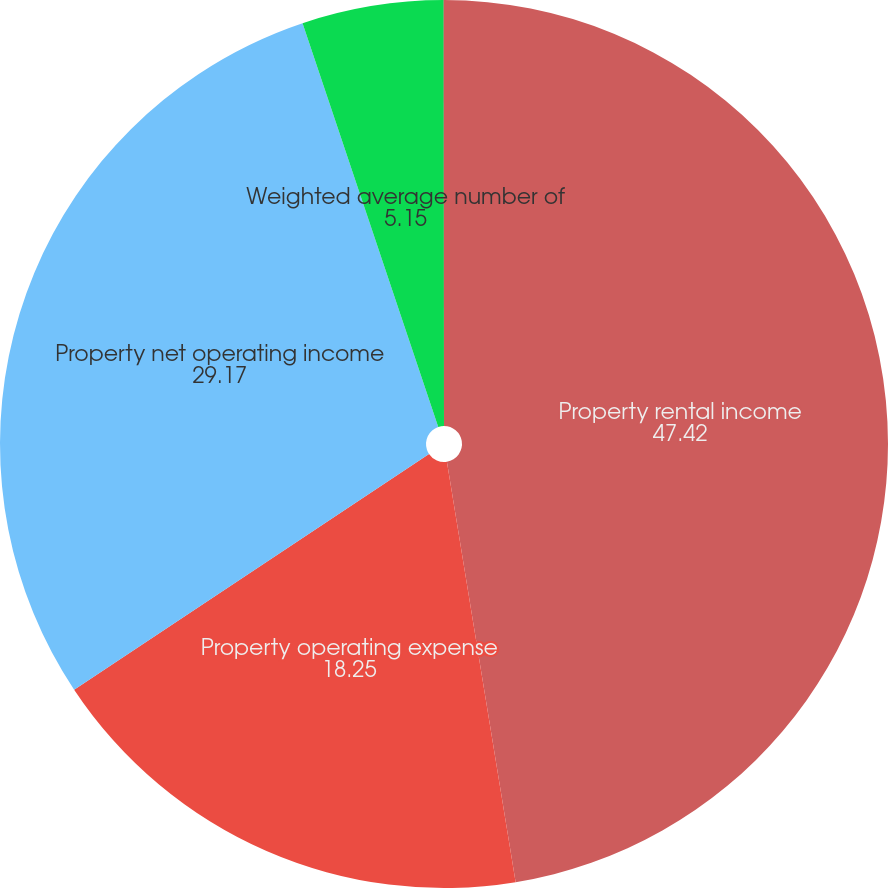Convert chart. <chart><loc_0><loc_0><loc_500><loc_500><pie_chart><fcel>Property rental income<fcel>Property operating expense<fcel>Property net operating income<fcel>Weighted average number of<fcel>Physical occupancy<nl><fcel>47.42%<fcel>18.25%<fcel>29.17%<fcel>5.15%<fcel>0.01%<nl></chart> 